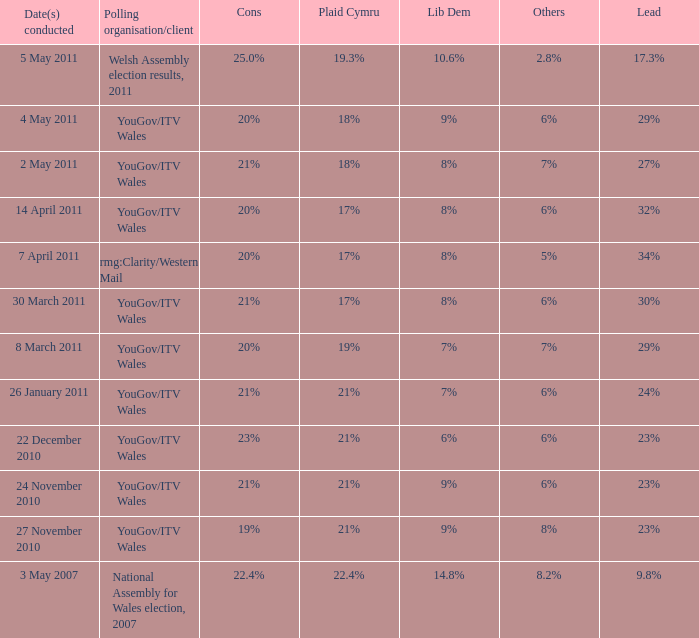What is the cons for lib dem of 8% and a lead of 27% 21%. Could you parse the entire table as a dict? {'header': ['Date(s) conducted', 'Polling organisation/client', 'Cons', 'Plaid Cymru', 'Lib Dem', 'Others', 'Lead'], 'rows': [['5 May 2011', 'Welsh Assembly election results, 2011', '25.0%', '19.3%', '10.6%', '2.8%', '17.3%'], ['4 May 2011', 'YouGov/ITV Wales', '20%', '18%', '9%', '6%', '29%'], ['2 May 2011', 'YouGov/ITV Wales', '21%', '18%', '8%', '7%', '27%'], ['14 April 2011', 'YouGov/ITV Wales', '20%', '17%', '8%', '6%', '32%'], ['7 April 2011', 'rmg:Clarity/Western Mail', '20%', '17%', '8%', '5%', '34%'], ['30 March 2011', 'YouGov/ITV Wales', '21%', '17%', '8%', '6%', '30%'], ['8 March 2011', 'YouGov/ITV Wales', '20%', '19%', '7%', '7%', '29%'], ['26 January 2011', 'YouGov/ITV Wales', '21%', '21%', '7%', '6%', '24%'], ['22 December 2010', 'YouGov/ITV Wales', '23%', '21%', '6%', '6%', '23%'], ['24 November 2010', 'YouGov/ITV Wales', '21%', '21%', '9%', '6%', '23%'], ['27 November 2010', 'YouGov/ITV Wales', '19%', '21%', '9%', '8%', '23%'], ['3 May 2007', 'National Assembly for Wales election, 2007', '22.4%', '22.4%', '14.8%', '8.2%', '9.8%']]} 